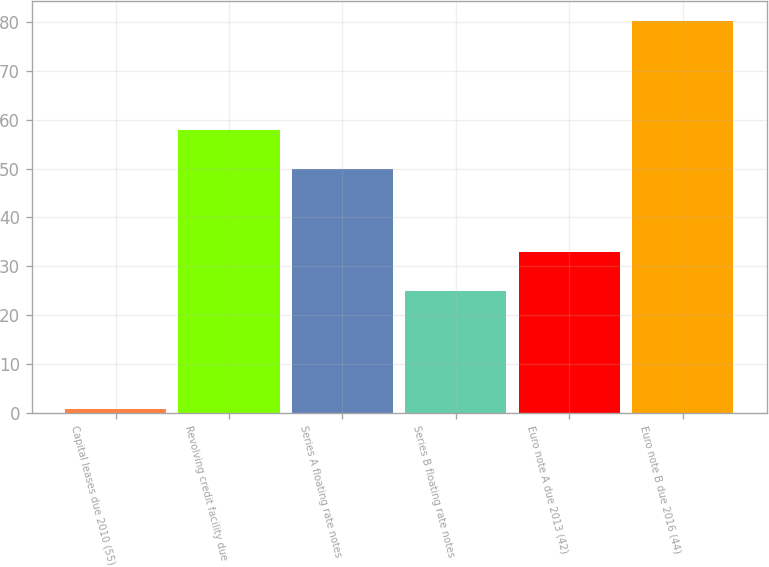Convert chart. <chart><loc_0><loc_0><loc_500><loc_500><bar_chart><fcel>Capital leases due 2010 (55)<fcel>Revolving credit facility due<fcel>Series A floating rate notes<fcel>Series B floating rate notes<fcel>Euro note A due 2013 (42)<fcel>Euro note B due 2016 (44)<nl><fcel>0.7<fcel>57.96<fcel>50<fcel>25<fcel>32.96<fcel>80.3<nl></chart> 